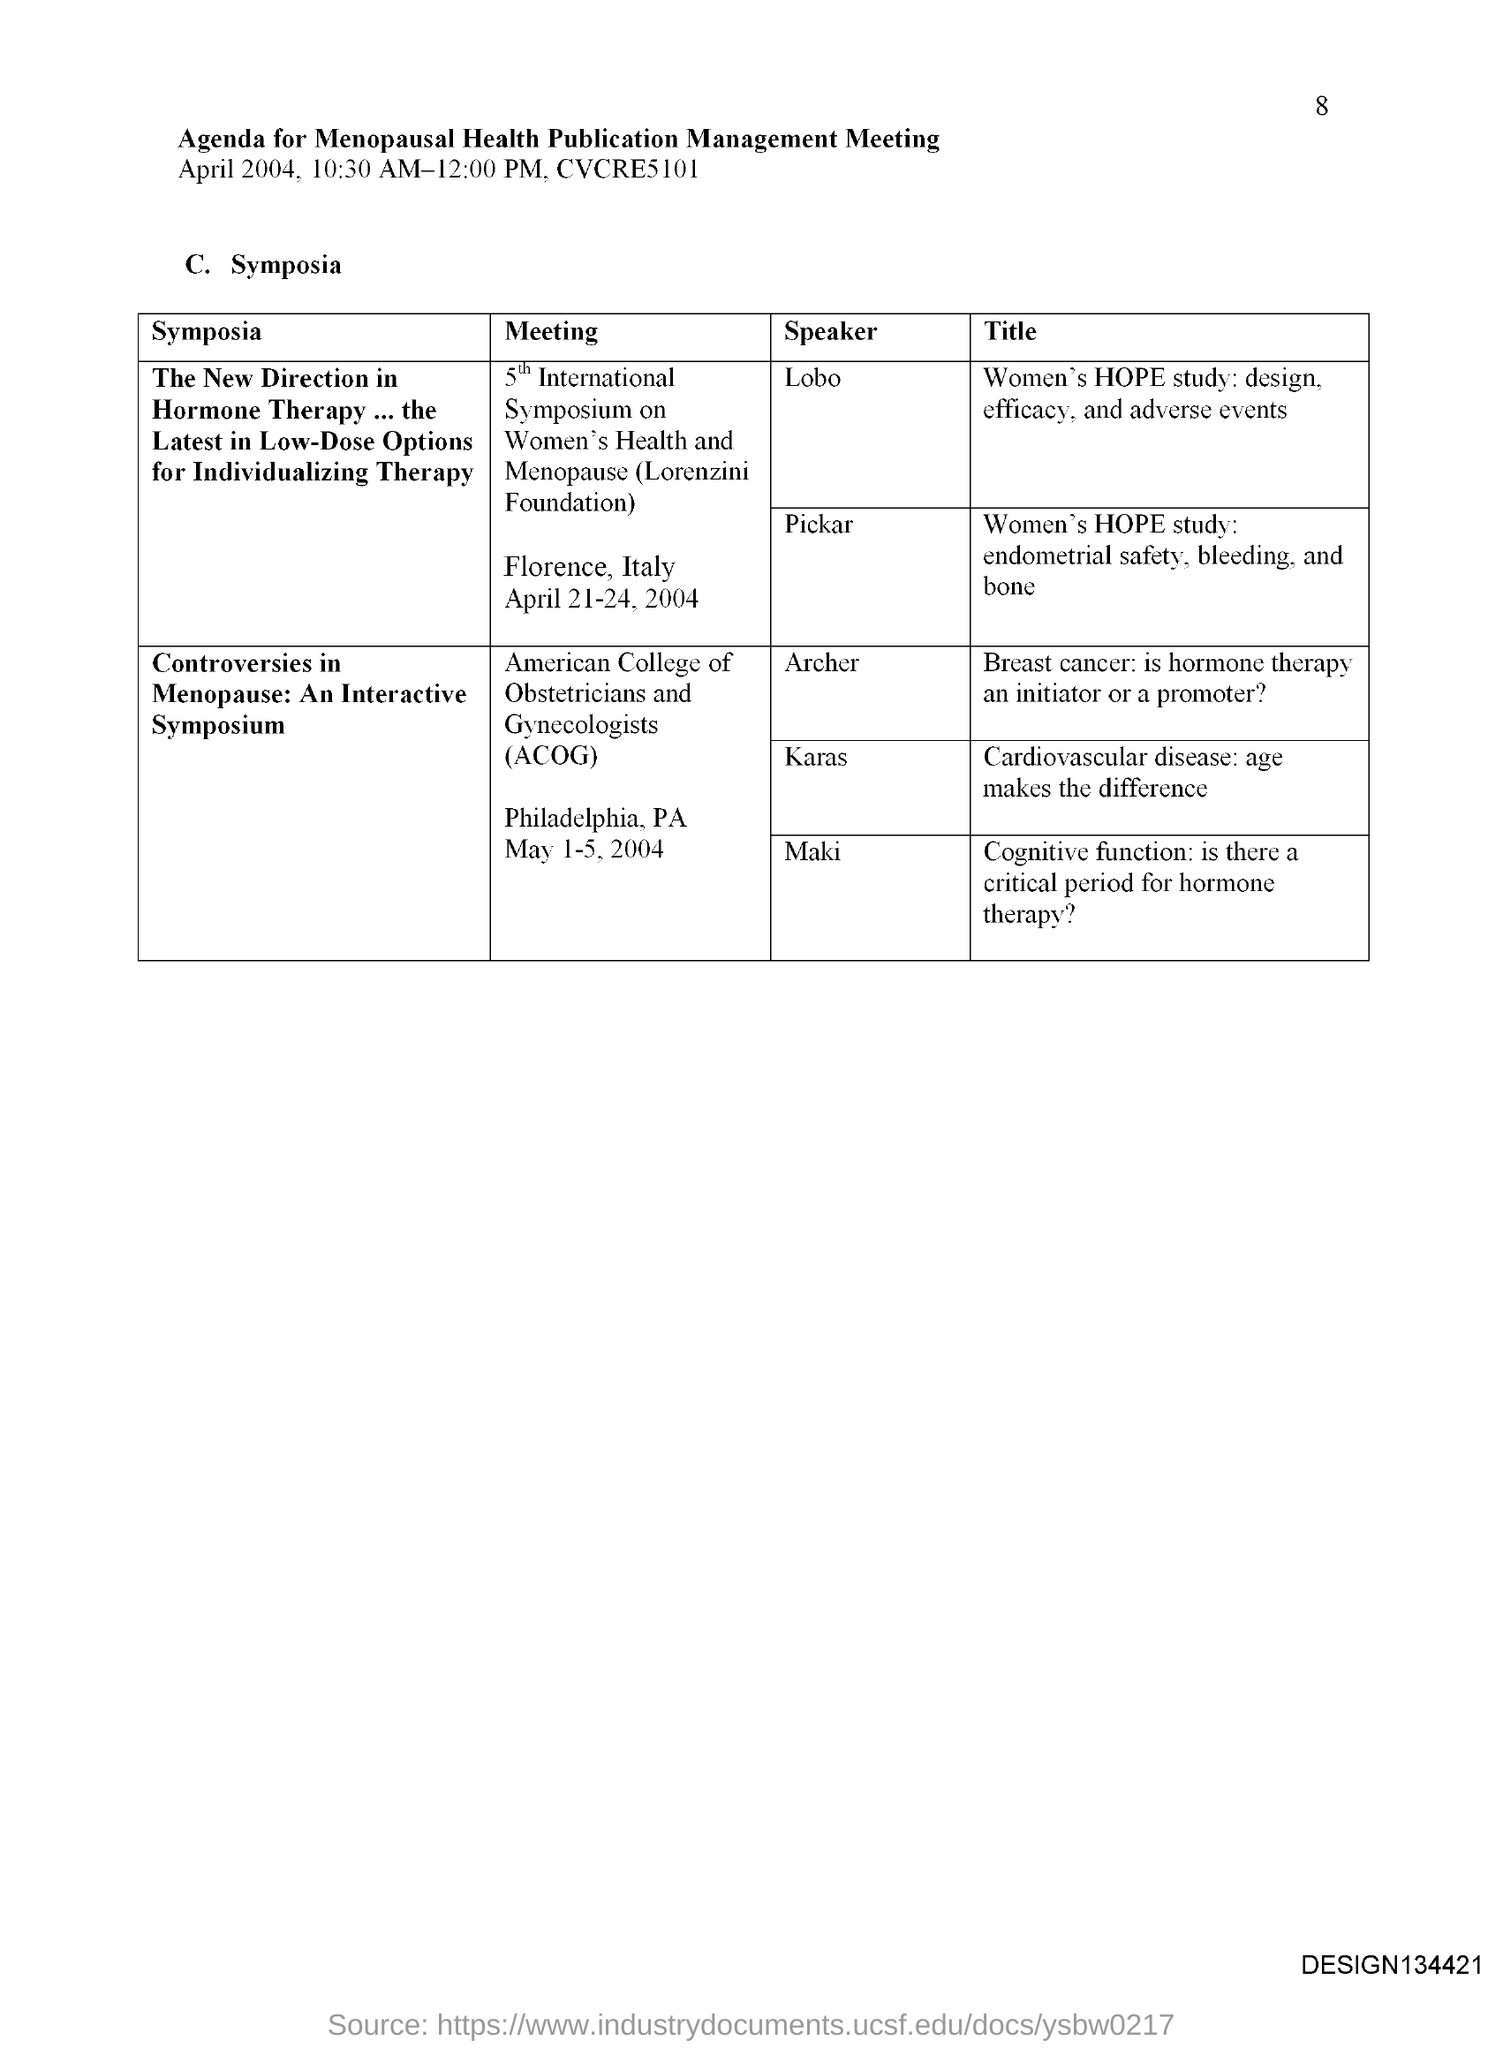Indicate a few pertinent items in this graphic. The page number is 8," the declaration states. The document titled 'Agenda for Menopausal Health Publication Management Meeting' is a document that provides information regarding the management of publications related to menopausal health. 